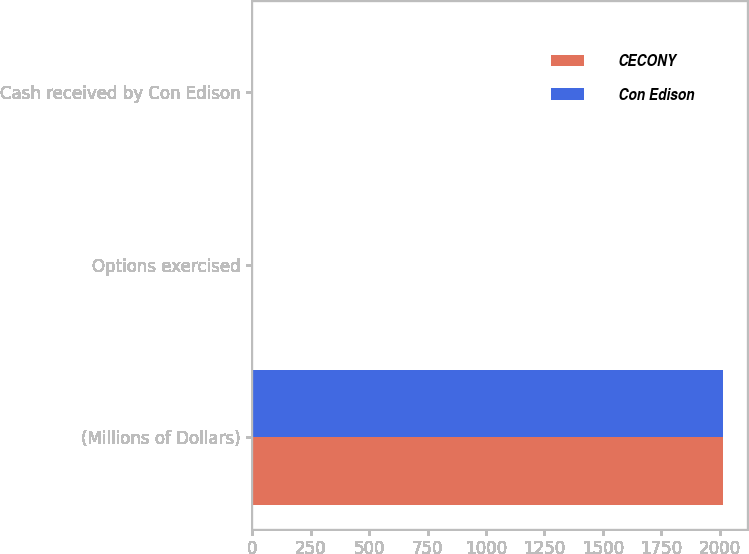Convert chart to OTSL. <chart><loc_0><loc_0><loc_500><loc_500><stacked_bar_chart><ecel><fcel>(Millions of Dollars)<fcel>Options exercised<fcel>Cash received by Con Edison<nl><fcel>CECONY<fcel>2016<fcel>2<fcel>3<nl><fcel>Con Edison<fcel>2016<fcel>2<fcel>3<nl></chart> 